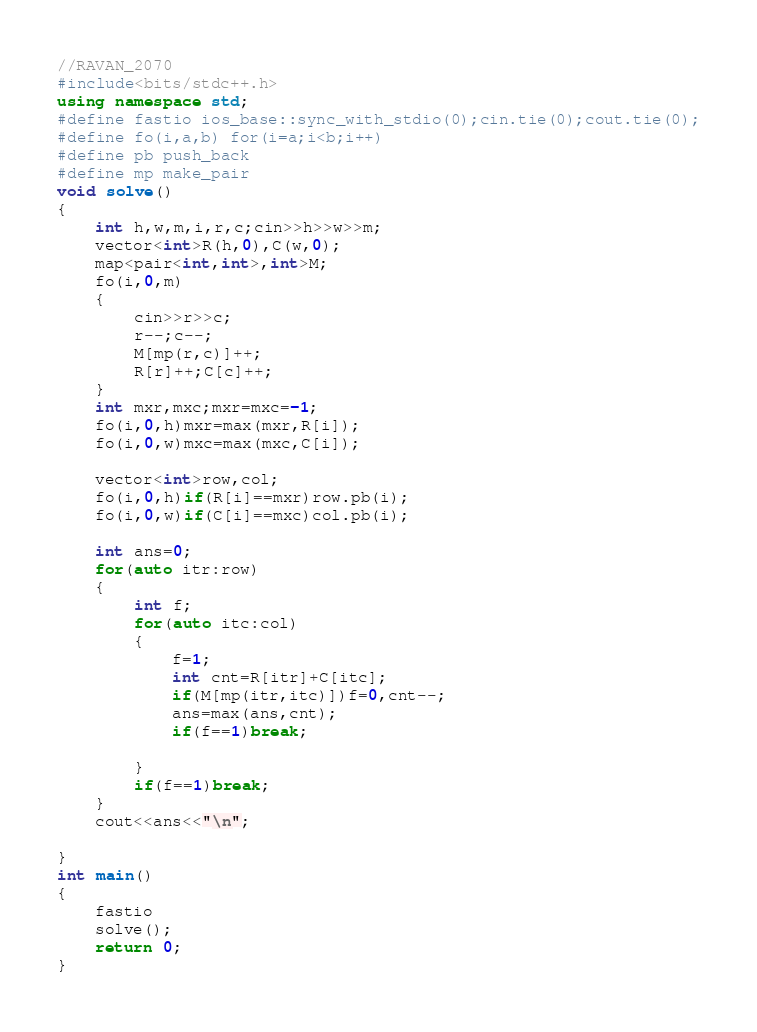<code> <loc_0><loc_0><loc_500><loc_500><_C++_>//RAVAN_2070
#include<bits/stdc++.h>
using namespace std;
#define fastio ios_base::sync_with_stdio(0);cin.tie(0);cout.tie(0);
#define fo(i,a,b) for(i=a;i<b;i++)
#define pb push_back
#define mp make_pair
void solve()
{
    int h,w,m,i,r,c;cin>>h>>w>>m;
    vector<int>R(h,0),C(w,0);
    map<pair<int,int>,int>M;
    fo(i,0,m)
    {
        cin>>r>>c;
        r--;c--;
        M[mp(r,c)]++;
        R[r]++;C[c]++;
    }
    int mxr,mxc;mxr=mxc=-1;
    fo(i,0,h)mxr=max(mxr,R[i]);
    fo(i,0,w)mxc=max(mxc,C[i]);

    vector<int>row,col;
    fo(i,0,h)if(R[i]==mxr)row.pb(i);
    fo(i,0,w)if(C[i]==mxc)col.pb(i);

    int ans=0;
    for(auto itr:row)
    {
        int f;
        for(auto itc:col)
        {
            f=1;
            int cnt=R[itr]+C[itc];
            if(M[mp(itr,itc)])f=0,cnt--;
            ans=max(ans,cnt);
            if(f==1)break;

        }
        if(f==1)break;
    }
    cout<<ans<<"\n";
    
}
int main()
{
    fastio
    solve();
    return 0;
}
</code> 